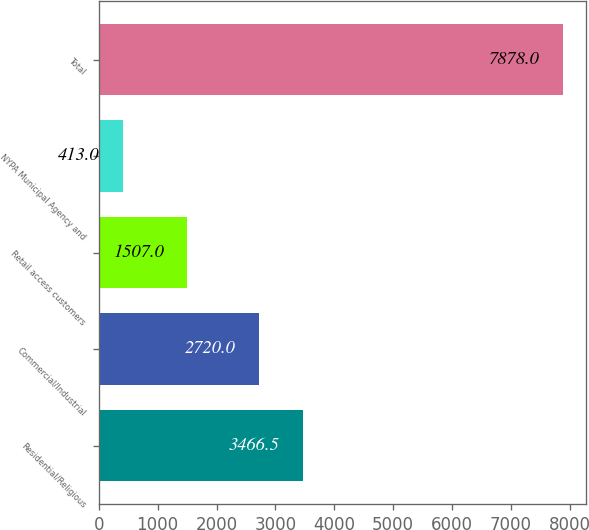Convert chart. <chart><loc_0><loc_0><loc_500><loc_500><bar_chart><fcel>Residential/Religious<fcel>Commercial/Industrial<fcel>Retail access customers<fcel>NYPA Municipal Agency and<fcel>Total<nl><fcel>3466.5<fcel>2720<fcel>1507<fcel>413<fcel>7878<nl></chart> 